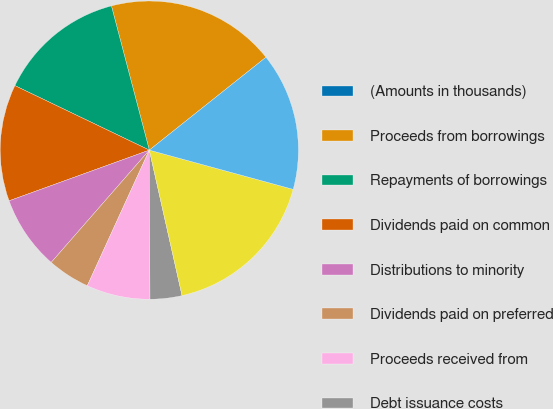<chart> <loc_0><loc_0><loc_500><loc_500><pie_chart><fcel>(Amounts in thousands)<fcel>Proceeds from borrowings<fcel>Repayments of borrowings<fcel>Dividends paid on common<fcel>Distributions to minority<fcel>Dividends paid on preferred<fcel>Proceeds received from<fcel>Debt issuance costs<fcel>Net cash provided by financing<fcel>Net (decrease) increase in<nl><fcel>0.0%<fcel>18.39%<fcel>13.79%<fcel>12.64%<fcel>8.05%<fcel>4.6%<fcel>6.9%<fcel>3.45%<fcel>17.24%<fcel>14.94%<nl></chart> 